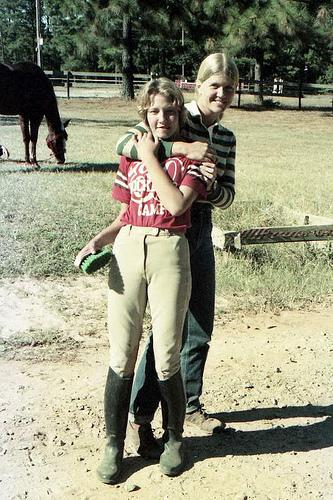Question: who is pictured?
Choices:
A. 2 males.
B. 2 babies.
C. 2 teens.
D. 2 females.
Answer with the letter. Answer: D Question: why are they embraced?
Choices:
A. Kissing.
B. For pic.
C. Hugging.
D. Miss each other.
Answer with the letter. Answer: B Question: what animal is there?
Choices:
A. Horse.
B. Cow.
C. Elephant.
D. Cat.
Answer with the letter. Answer: A Question: when is this scene?
Choices:
A. Midnight.
B. Lunch time.
C. Daytime.
D. Dawn.
Answer with the letter. Answer: C Question: what is in the far back?
Choices:
A. Mountains.
B. Bridge.
C. Trees.
D. Ocean.
Answer with the letter. Answer: C Question: how vintage does this pic look?
Choices:
A. Not at all.
B. Very vintage.
C. 20 years.
D. 50 years.
Answer with the letter. Answer: B 